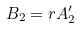Convert formula to latex. <formula><loc_0><loc_0><loc_500><loc_500>B _ { 2 } = r A _ { 2 } ^ { \prime }</formula> 